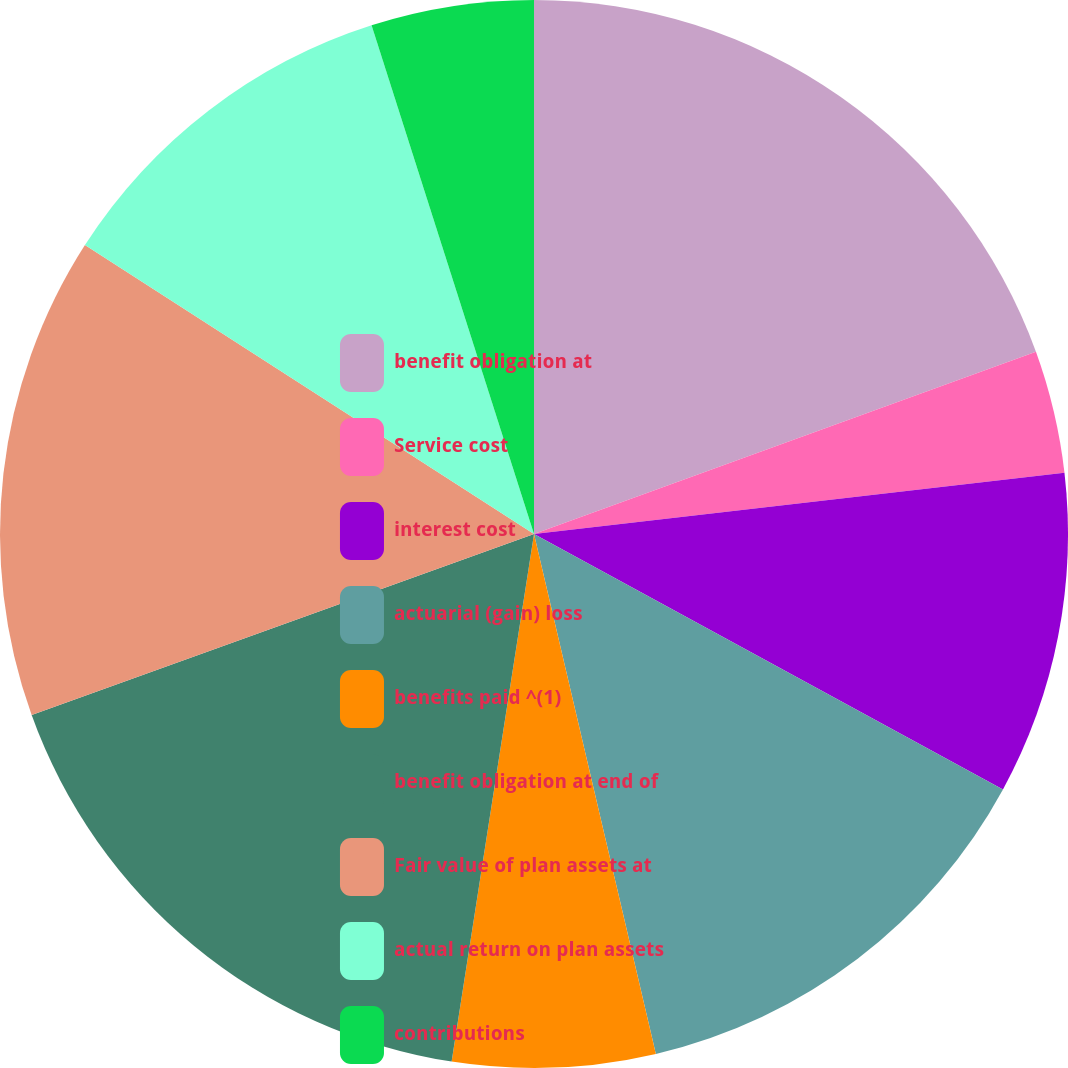<chart> <loc_0><loc_0><loc_500><loc_500><pie_chart><fcel>benefit obligation at<fcel>Service cost<fcel>interest cost<fcel>actuarial (gain) loss<fcel>benefits paid ^(1)<fcel>benefit obligation at end of<fcel>Fair value of plan assets at<fcel>actual return on plan assets<fcel>contributions<nl><fcel>19.46%<fcel>3.71%<fcel>9.77%<fcel>13.4%<fcel>6.13%<fcel>17.03%<fcel>14.61%<fcel>10.98%<fcel>4.92%<nl></chart> 